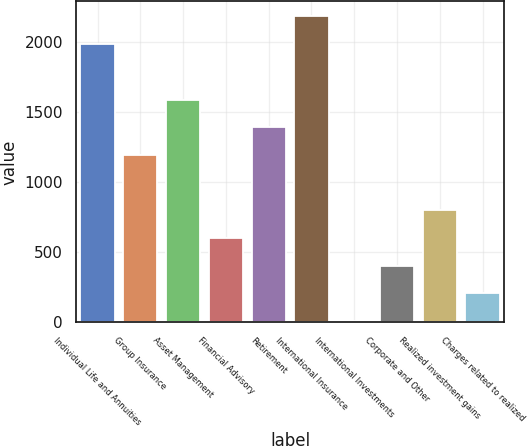<chart> <loc_0><loc_0><loc_500><loc_500><bar_chart><fcel>Individual Life and Annuities<fcel>Group Insurance<fcel>Asset Management<fcel>Financial Advisory<fcel>Retirement<fcel>International Insurance<fcel>International Investments<fcel>Corporate and Other<fcel>Realized investment gains<fcel>Charges related to realized<nl><fcel>1983<fcel>1193.8<fcel>1588.4<fcel>601.9<fcel>1391.1<fcel>2180.3<fcel>10<fcel>404.6<fcel>799.2<fcel>207.3<nl></chart> 